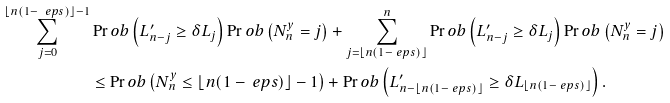Convert formula to latex. <formula><loc_0><loc_0><loc_500><loc_500>\sum _ { j = 0 } ^ { \lfloor n ( 1 - \ e p s ) \rfloor - 1 } & \Pr o b \left ( L ^ { \prime } _ { n - j } \geq \delta L _ { j } \right ) \Pr o b \left ( N _ { n } ^ { y } = j \right ) + \sum _ { j = \lfloor n ( 1 - \ e p s ) \rfloor } ^ { n } \Pr o b \left ( L ^ { \prime } _ { n - j } \geq \delta L _ { j } \right ) \Pr o b \left ( N _ { n } ^ { y } = j \right ) \\ & \leq \Pr o b \left ( N _ { n } ^ { y } \leq \lfloor n ( 1 - \ e p s ) \rfloor - 1 \right ) + \Pr o b \left ( L ^ { \prime } _ { n - \lfloor n ( 1 - \ e p s ) \rfloor } \geq \delta L _ { \lfloor n ( 1 - \ e p s ) \rfloor } \right ) .</formula> 